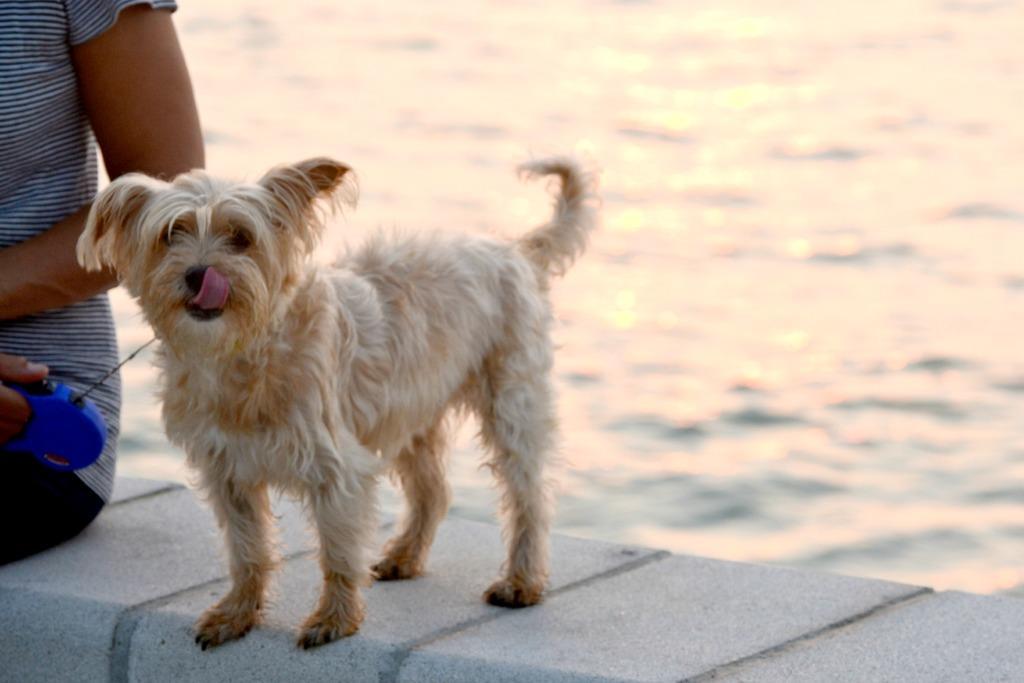How would you summarize this image in a sentence or two? There is a dog standing on a brick wall. On the left side there is a person holding something and a rope is attached to the dog. In the background there is water. 